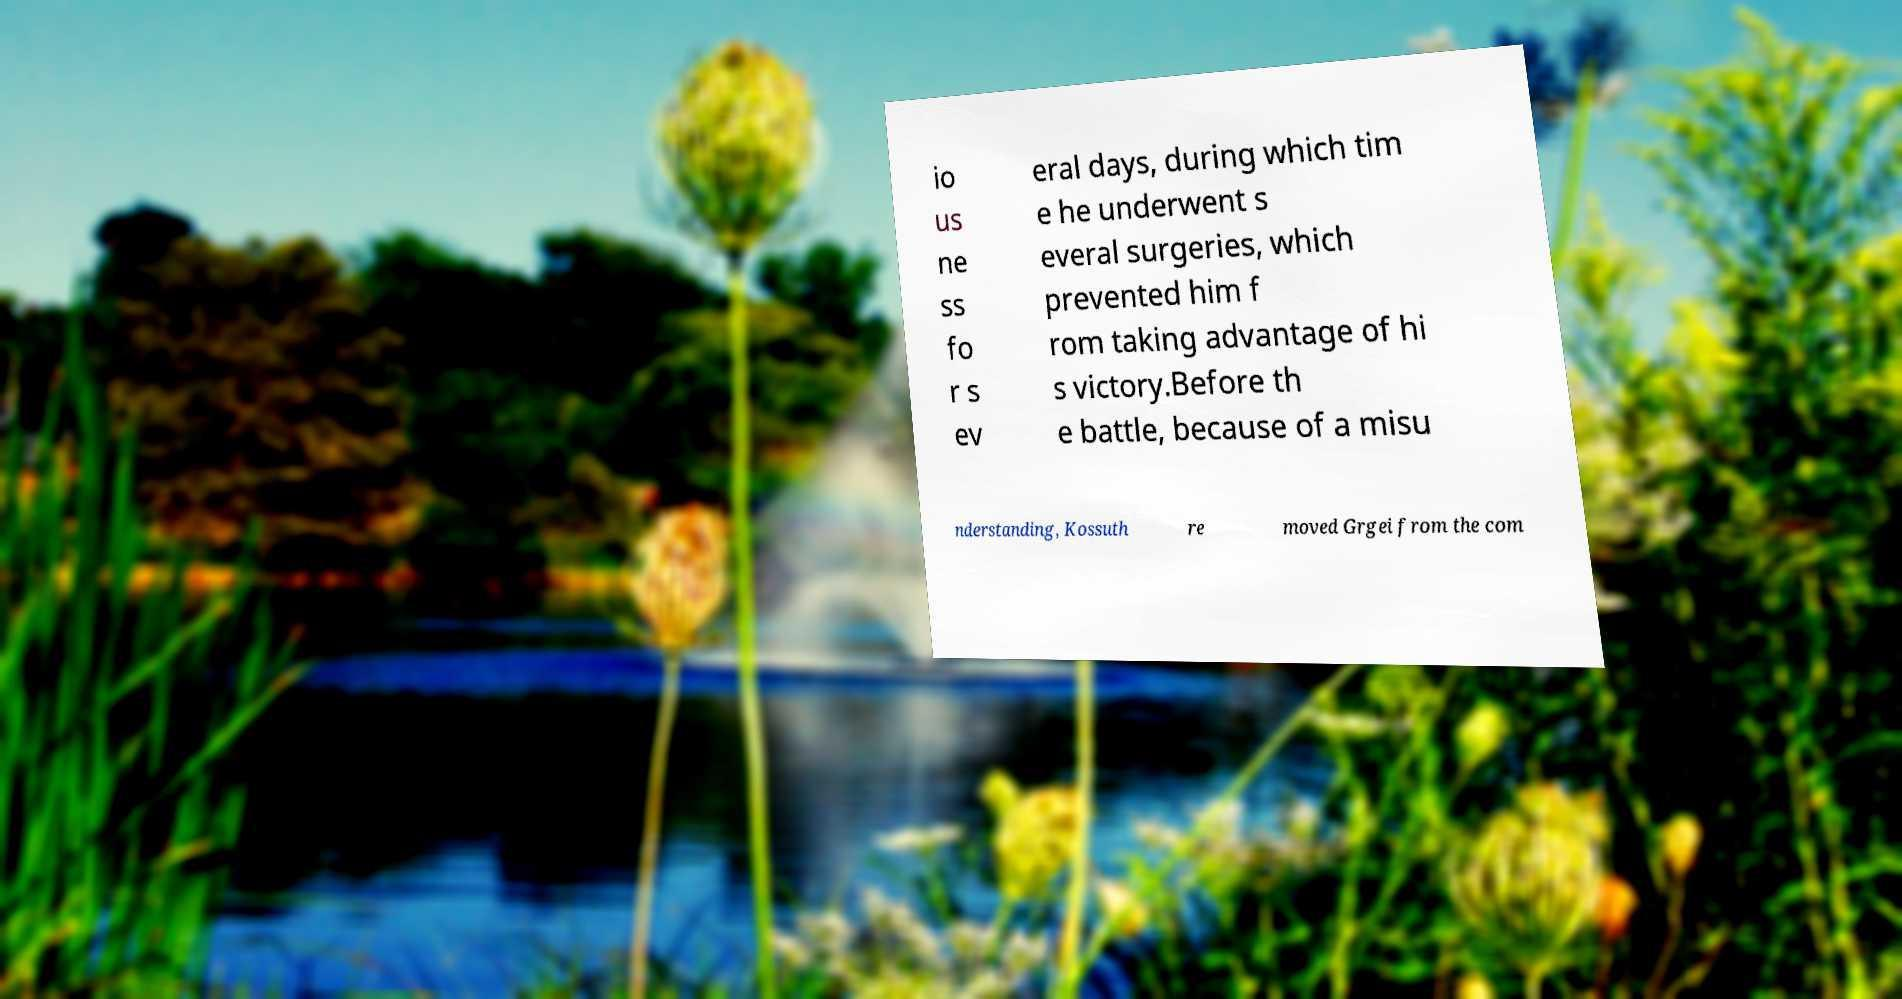Please read and relay the text visible in this image. What does it say? io us ne ss fo r s ev eral days, during which tim e he underwent s everal surgeries, which prevented him f rom taking advantage of hi s victory.Before th e battle, because of a misu nderstanding, Kossuth re moved Grgei from the com 